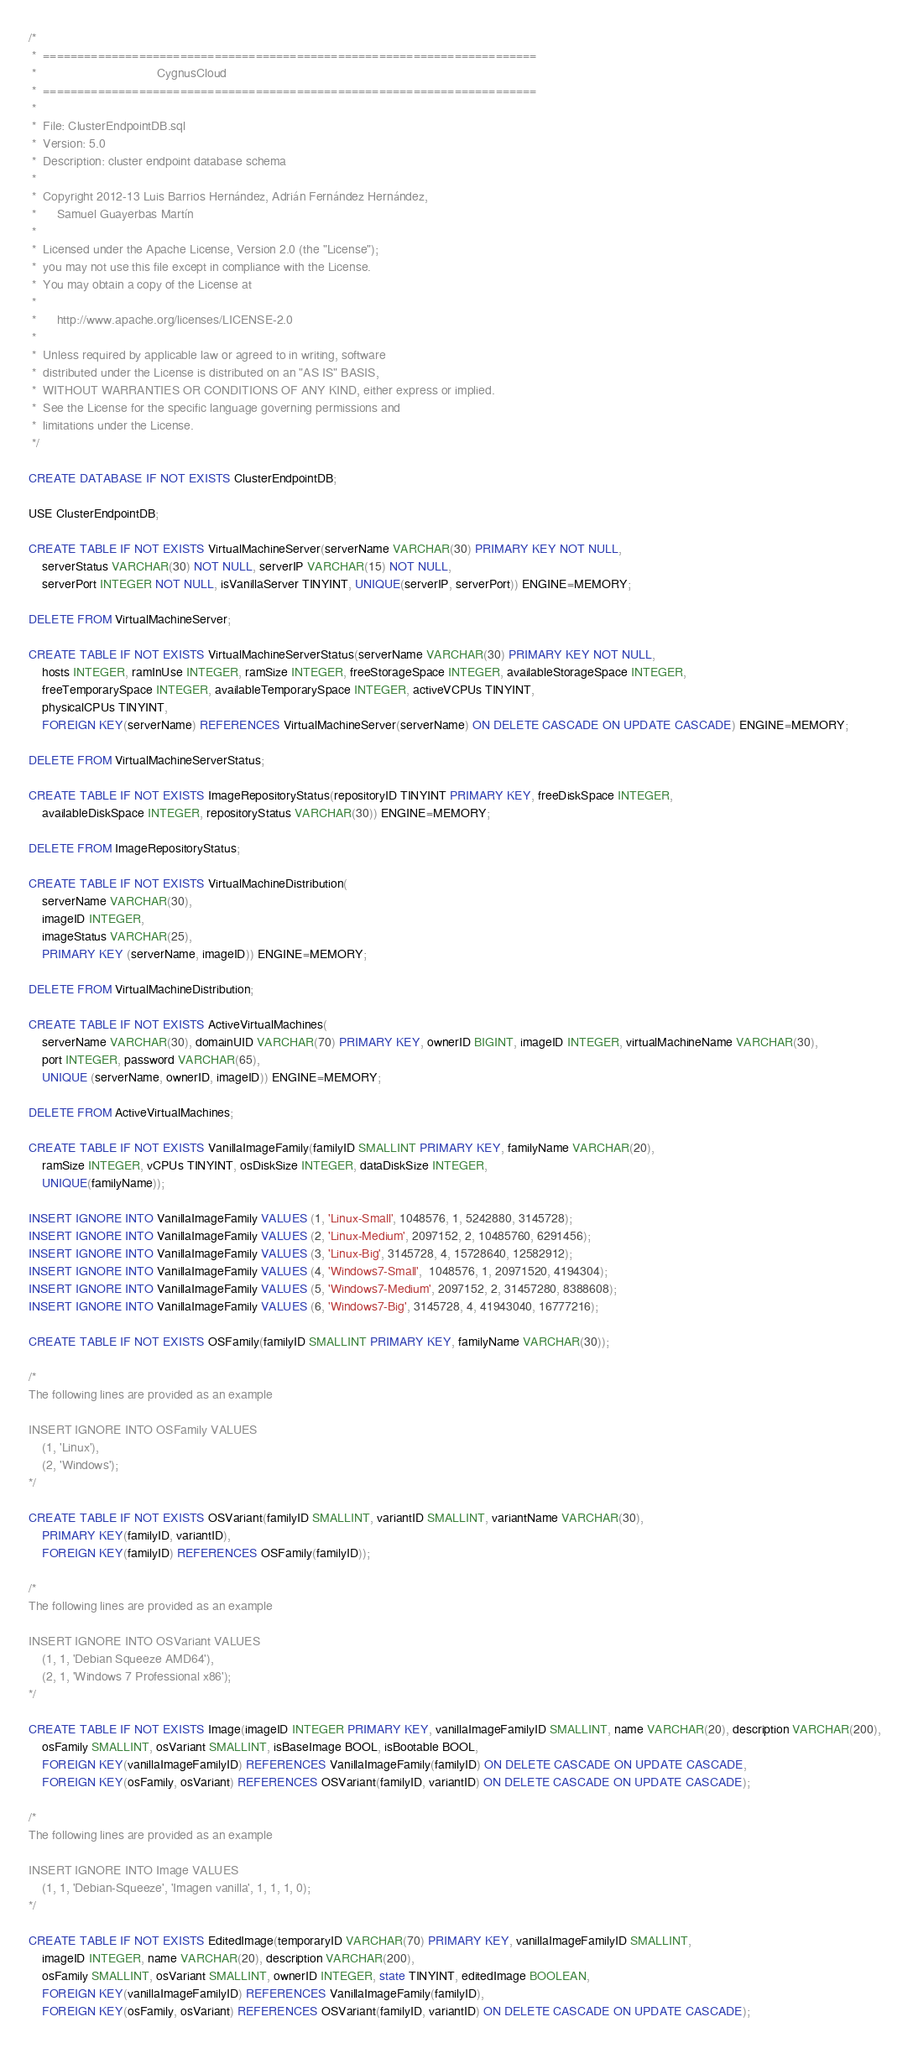Convert code to text. <code><loc_0><loc_0><loc_500><loc_500><_SQL_>/*
 *  ========================================================================
 *                                   CygnusCloud
 *  ======================================================================== 
 *
 *  File: ClusterEndpointDB.sql    
 *  Version: 5.0
 *  Description: cluster endpoint database schema 
 *
 *  Copyright 2012-13 Luis Barrios Hernández, Adrián Fernández Hernández,
 *      Samuel Guayerbas Martín       
 *
 *  Licensed under the Apache License, Version 2.0 (the "License");
 *  you may not use this file except in compliance with the License.
 *  You may obtain a copy of the License at
 *
 *      http://www.apache.org/licenses/LICENSE-2.0
 *
 *  Unless required by applicable law or agreed to in writing, software
 *  distributed under the License is distributed on an "AS IS" BASIS,
 *  WITHOUT WARRANTIES OR CONDITIONS OF ANY KIND, either express or implied.
 *  See the License for the specific language governing permissions and
 *  limitations under the License.
 */
 
CREATE DATABASE IF NOT EXISTS ClusterEndpointDB;

USE ClusterEndpointDB;
 
CREATE TABLE IF NOT EXISTS VirtualMachineServer(serverName VARCHAR(30) PRIMARY KEY NOT NULL, 
    serverStatus VARCHAR(30) NOT NULL, serverIP VARCHAR(15) NOT NULL,
    serverPort INTEGER NOT NULL, isVanillaServer TINYINT, UNIQUE(serverIP, serverPort)) ENGINE=MEMORY;
    
DELETE FROM VirtualMachineServer;

CREATE TABLE IF NOT EXISTS VirtualMachineServerStatus(serverName VARCHAR(30) PRIMARY KEY NOT NULL, 
	hosts INTEGER, ramInUse INTEGER, ramSize INTEGER, freeStorageSpace INTEGER, availableStorageSpace INTEGER,
	freeTemporarySpace INTEGER, availableTemporarySpace INTEGER, activeVCPUs TINYINT,
	physicalCPUs TINYINT, 
	FOREIGN KEY(serverName) REFERENCES VirtualMachineServer(serverName) ON DELETE CASCADE ON UPDATE CASCADE) ENGINE=MEMORY;
	
DELETE FROM VirtualMachineServerStatus;

CREATE TABLE IF NOT EXISTS ImageRepositoryStatus(repositoryID TINYINT PRIMARY KEY, freeDiskSpace INTEGER,
	availableDiskSpace INTEGER, repositoryStatus VARCHAR(30)) ENGINE=MEMORY;
	
DELETE FROM ImageRepositoryStatus;

CREATE TABLE IF NOT EXISTS VirtualMachineDistribution(
    serverName VARCHAR(30),
    imageID INTEGER,
    imageStatus VARCHAR(25),
    PRIMARY KEY (serverName, imageID)) ENGINE=MEMORY;

DELETE FROM VirtualMachineDistribution;
        
CREATE TABLE IF NOT EXISTS ActiveVirtualMachines(
	serverName VARCHAR(30), domainUID VARCHAR(70) PRIMARY KEY, ownerID BIGINT, imageID INTEGER, virtualMachineName VARCHAR(30),
	port INTEGER, password VARCHAR(65),
	UNIQUE (serverName, ownerID, imageID)) ENGINE=MEMORY;
	
DELETE FROM ActiveVirtualMachines;

CREATE TABLE IF NOT EXISTS VanillaImageFamily(familyID SMALLINT PRIMARY KEY, familyName VARCHAR(20),
    ramSize INTEGER, vCPUs TINYINT, osDiskSize INTEGER, dataDiskSize INTEGER,
    UNIQUE(familyName));
    
INSERT IGNORE INTO VanillaImageFamily VALUES (1, 'Linux-Small', 1048576, 1, 5242880, 3145728); 
INSERT IGNORE INTO VanillaImageFamily VALUES (2, 'Linux-Medium', 2097152, 2, 10485760, 6291456);
INSERT IGNORE INTO VanillaImageFamily VALUES (3, 'Linux-Big', 3145728, 4, 15728640, 12582912);
INSERT IGNORE INTO VanillaImageFamily VALUES (4, 'Windows7-Small',  1048576, 1, 20971520, 4194304);
INSERT IGNORE INTO VanillaImageFamily VALUES (5, 'Windows7-Medium', 2097152, 2, 31457280, 8388608);
INSERT IGNORE INTO VanillaImageFamily VALUES (6, 'Windows7-Big', 3145728, 4, 41943040, 16777216);

CREATE TABLE IF NOT EXISTS OSFamily(familyID SMALLINT PRIMARY KEY, familyName VARCHAR(30));

/*
The following lines are provided as an example

INSERT IGNORE INTO OSFamily VALUES
	(1, 'Linux'),
	(2, 'Windows');
*/
	
CREATE TABLE IF NOT EXISTS OSVariant(familyID SMALLINT, variantID SMALLINT, variantName VARCHAR(30),
	PRIMARY KEY(familyID, variantID),
	FOREIGN KEY(familyID) REFERENCES OSFamily(familyID));

/*
The following lines are provided as an example

INSERT IGNORE INTO OSVariant VALUES
	(1, 1, 'Debian Squeeze AMD64'),
	(2, 1, 'Windows 7 Professional x86');
*/
	
CREATE TABLE IF NOT EXISTS Image(imageID INTEGER PRIMARY KEY, vanillaImageFamilyID SMALLINT, name VARCHAR(20), description VARCHAR(200), 
	osFamily SMALLINT, osVariant SMALLINT, isBaseImage BOOL, isBootable BOOL,
	FOREIGN KEY(vanillaImageFamilyID) REFERENCES VanillaImageFamily(familyID) ON DELETE CASCADE ON UPDATE CASCADE,
	FOREIGN KEY(osFamily, osVariant) REFERENCES OSVariant(familyID, variantID) ON DELETE CASCADE ON UPDATE CASCADE);

/*
The following lines are provided as an example

INSERT IGNORE INTO Image VALUES
	(1, 1, 'Debian-Squeeze', 'Imagen vanilla', 1, 1, 1, 0);
*/
	
CREATE TABLE IF NOT EXISTS EditedImage(temporaryID VARCHAR(70) PRIMARY KEY, vanillaImageFamilyID SMALLINT, 
	imageID INTEGER, name VARCHAR(20), description VARCHAR(200),
	osFamily SMALLINT, osVariant SMALLINT, ownerID INTEGER, state TINYINT, editedImage BOOLEAN,
	FOREIGN KEY(vanillaImageFamilyID) REFERENCES VanillaImageFamily(familyID),
	FOREIGN KEY(osFamily, osVariant) REFERENCES OSVariant(familyID, variantID) ON DELETE CASCADE ON UPDATE CASCADE);
</code> 